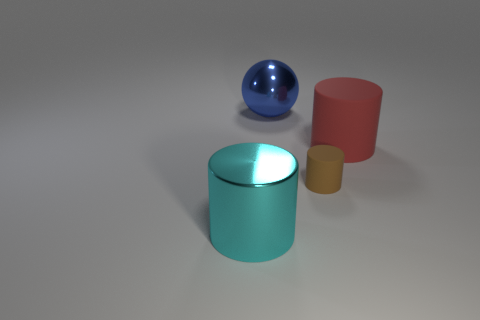Add 4 small green rubber blocks. How many objects exist? 8 Subtract all balls. How many objects are left? 3 Subtract 1 blue spheres. How many objects are left? 3 Subtract all large cyan shiny cylinders. Subtract all large purple objects. How many objects are left? 3 Add 3 red rubber cylinders. How many red rubber cylinders are left? 4 Add 3 big blue things. How many big blue things exist? 4 